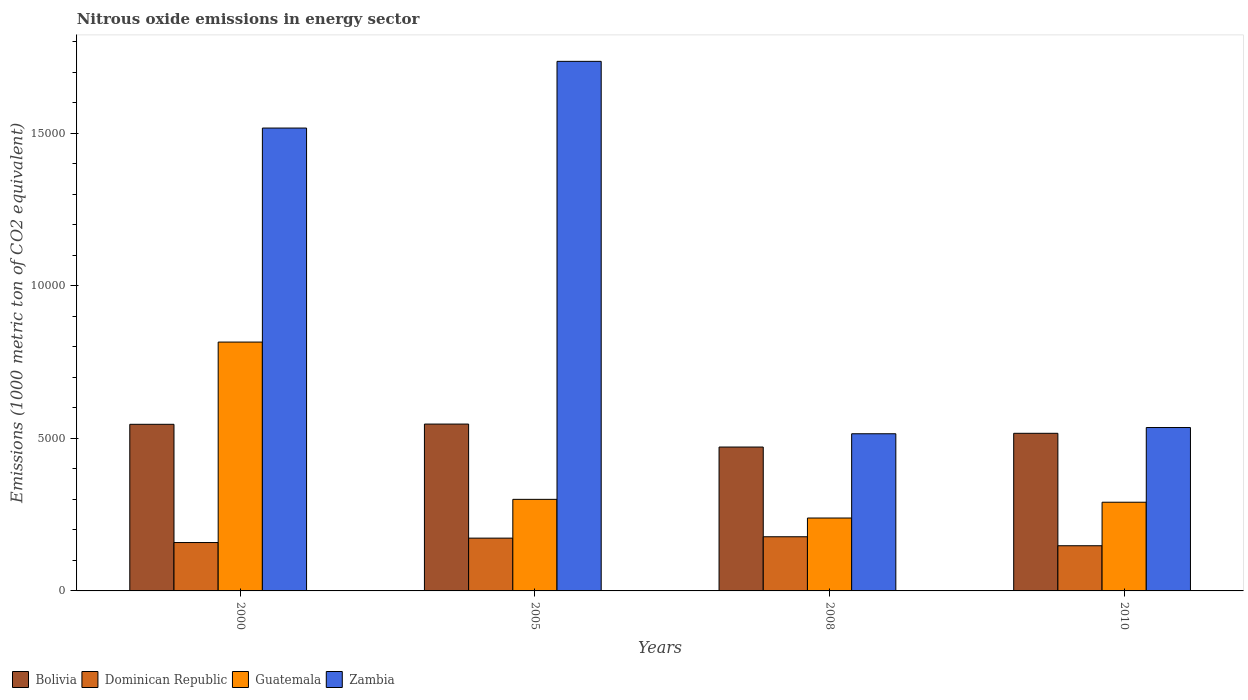How many groups of bars are there?
Provide a short and direct response. 4. Are the number of bars on each tick of the X-axis equal?
Give a very brief answer. Yes. How many bars are there on the 1st tick from the right?
Your answer should be very brief. 4. What is the amount of nitrous oxide emitted in Bolivia in 2000?
Offer a terse response. 5463.1. Across all years, what is the maximum amount of nitrous oxide emitted in Dominican Republic?
Offer a very short reply. 1775.7. Across all years, what is the minimum amount of nitrous oxide emitted in Zambia?
Provide a short and direct response. 5152.9. In which year was the amount of nitrous oxide emitted in Zambia maximum?
Give a very brief answer. 2005. What is the total amount of nitrous oxide emitted in Zambia in the graph?
Make the answer very short. 4.30e+04. What is the difference between the amount of nitrous oxide emitted in Zambia in 2000 and that in 2010?
Offer a very short reply. 9818.5. What is the difference between the amount of nitrous oxide emitted in Dominican Republic in 2010 and the amount of nitrous oxide emitted in Guatemala in 2005?
Your answer should be very brief. -1520.9. What is the average amount of nitrous oxide emitted in Dominican Republic per year?
Your response must be concise. 1643.65. In the year 2000, what is the difference between the amount of nitrous oxide emitted in Zambia and amount of nitrous oxide emitted in Dominican Republic?
Your answer should be very brief. 1.36e+04. What is the ratio of the amount of nitrous oxide emitted in Dominican Republic in 2005 to that in 2010?
Your answer should be compact. 1.17. Is the amount of nitrous oxide emitted in Guatemala in 2005 less than that in 2010?
Keep it short and to the point. No. Is the difference between the amount of nitrous oxide emitted in Zambia in 2005 and 2008 greater than the difference between the amount of nitrous oxide emitted in Dominican Republic in 2005 and 2008?
Your answer should be compact. Yes. What is the difference between the highest and the second highest amount of nitrous oxide emitted in Dominican Republic?
Make the answer very short. 44.7. What is the difference between the highest and the lowest amount of nitrous oxide emitted in Guatemala?
Keep it short and to the point. 5769.4. In how many years, is the amount of nitrous oxide emitted in Bolivia greater than the average amount of nitrous oxide emitted in Bolivia taken over all years?
Provide a short and direct response. 2. Is it the case that in every year, the sum of the amount of nitrous oxide emitted in Bolivia and amount of nitrous oxide emitted in Dominican Republic is greater than the sum of amount of nitrous oxide emitted in Zambia and amount of nitrous oxide emitted in Guatemala?
Your answer should be very brief. Yes. What does the 2nd bar from the left in 2005 represents?
Offer a very short reply. Dominican Republic. What does the 1st bar from the right in 2000 represents?
Make the answer very short. Zambia. Are all the bars in the graph horizontal?
Keep it short and to the point. No. How many legend labels are there?
Give a very brief answer. 4. How are the legend labels stacked?
Provide a succinct answer. Horizontal. What is the title of the graph?
Provide a short and direct response. Nitrous oxide emissions in energy sector. Does "Tajikistan" appear as one of the legend labels in the graph?
Offer a terse response. No. What is the label or title of the Y-axis?
Offer a terse response. Emissions (1000 metric ton of CO2 equivalent). What is the Emissions (1000 metric ton of CO2 equivalent) of Bolivia in 2000?
Keep it short and to the point. 5463.1. What is the Emissions (1000 metric ton of CO2 equivalent) in Dominican Republic in 2000?
Your answer should be very brief. 1586.4. What is the Emissions (1000 metric ton of CO2 equivalent) of Guatemala in 2000?
Your answer should be very brief. 8159.4. What is the Emissions (1000 metric ton of CO2 equivalent) in Zambia in 2000?
Your response must be concise. 1.52e+04. What is the Emissions (1000 metric ton of CO2 equivalent) of Bolivia in 2005?
Your answer should be very brief. 5470.8. What is the Emissions (1000 metric ton of CO2 equivalent) in Dominican Republic in 2005?
Offer a very short reply. 1731. What is the Emissions (1000 metric ton of CO2 equivalent) of Guatemala in 2005?
Your answer should be compact. 3002.4. What is the Emissions (1000 metric ton of CO2 equivalent) of Zambia in 2005?
Provide a succinct answer. 1.74e+04. What is the Emissions (1000 metric ton of CO2 equivalent) of Bolivia in 2008?
Give a very brief answer. 4717.4. What is the Emissions (1000 metric ton of CO2 equivalent) in Dominican Republic in 2008?
Your response must be concise. 1775.7. What is the Emissions (1000 metric ton of CO2 equivalent) in Guatemala in 2008?
Make the answer very short. 2390. What is the Emissions (1000 metric ton of CO2 equivalent) of Zambia in 2008?
Your response must be concise. 5152.9. What is the Emissions (1000 metric ton of CO2 equivalent) in Bolivia in 2010?
Provide a short and direct response. 5168. What is the Emissions (1000 metric ton of CO2 equivalent) in Dominican Republic in 2010?
Provide a short and direct response. 1481.5. What is the Emissions (1000 metric ton of CO2 equivalent) in Guatemala in 2010?
Your answer should be compact. 2908.1. What is the Emissions (1000 metric ton of CO2 equivalent) in Zambia in 2010?
Provide a succinct answer. 5357.6. Across all years, what is the maximum Emissions (1000 metric ton of CO2 equivalent) of Bolivia?
Your response must be concise. 5470.8. Across all years, what is the maximum Emissions (1000 metric ton of CO2 equivalent) in Dominican Republic?
Your answer should be very brief. 1775.7. Across all years, what is the maximum Emissions (1000 metric ton of CO2 equivalent) of Guatemala?
Your answer should be very brief. 8159.4. Across all years, what is the maximum Emissions (1000 metric ton of CO2 equivalent) in Zambia?
Your answer should be compact. 1.74e+04. Across all years, what is the minimum Emissions (1000 metric ton of CO2 equivalent) of Bolivia?
Offer a very short reply. 4717.4. Across all years, what is the minimum Emissions (1000 metric ton of CO2 equivalent) of Dominican Republic?
Give a very brief answer. 1481.5. Across all years, what is the minimum Emissions (1000 metric ton of CO2 equivalent) in Guatemala?
Provide a succinct answer. 2390. Across all years, what is the minimum Emissions (1000 metric ton of CO2 equivalent) of Zambia?
Your response must be concise. 5152.9. What is the total Emissions (1000 metric ton of CO2 equivalent) in Bolivia in the graph?
Ensure brevity in your answer.  2.08e+04. What is the total Emissions (1000 metric ton of CO2 equivalent) in Dominican Republic in the graph?
Give a very brief answer. 6574.6. What is the total Emissions (1000 metric ton of CO2 equivalent) in Guatemala in the graph?
Offer a very short reply. 1.65e+04. What is the total Emissions (1000 metric ton of CO2 equivalent) of Zambia in the graph?
Your answer should be compact. 4.30e+04. What is the difference between the Emissions (1000 metric ton of CO2 equivalent) of Bolivia in 2000 and that in 2005?
Provide a short and direct response. -7.7. What is the difference between the Emissions (1000 metric ton of CO2 equivalent) of Dominican Republic in 2000 and that in 2005?
Keep it short and to the point. -144.6. What is the difference between the Emissions (1000 metric ton of CO2 equivalent) of Guatemala in 2000 and that in 2005?
Offer a very short reply. 5157. What is the difference between the Emissions (1000 metric ton of CO2 equivalent) in Zambia in 2000 and that in 2005?
Your answer should be compact. -2187.2. What is the difference between the Emissions (1000 metric ton of CO2 equivalent) of Bolivia in 2000 and that in 2008?
Provide a succinct answer. 745.7. What is the difference between the Emissions (1000 metric ton of CO2 equivalent) of Dominican Republic in 2000 and that in 2008?
Ensure brevity in your answer.  -189.3. What is the difference between the Emissions (1000 metric ton of CO2 equivalent) in Guatemala in 2000 and that in 2008?
Your answer should be very brief. 5769.4. What is the difference between the Emissions (1000 metric ton of CO2 equivalent) of Zambia in 2000 and that in 2008?
Make the answer very short. 1.00e+04. What is the difference between the Emissions (1000 metric ton of CO2 equivalent) in Bolivia in 2000 and that in 2010?
Give a very brief answer. 295.1. What is the difference between the Emissions (1000 metric ton of CO2 equivalent) in Dominican Republic in 2000 and that in 2010?
Keep it short and to the point. 104.9. What is the difference between the Emissions (1000 metric ton of CO2 equivalent) of Guatemala in 2000 and that in 2010?
Offer a very short reply. 5251.3. What is the difference between the Emissions (1000 metric ton of CO2 equivalent) of Zambia in 2000 and that in 2010?
Your response must be concise. 9818.5. What is the difference between the Emissions (1000 metric ton of CO2 equivalent) in Bolivia in 2005 and that in 2008?
Your answer should be compact. 753.4. What is the difference between the Emissions (1000 metric ton of CO2 equivalent) in Dominican Republic in 2005 and that in 2008?
Your answer should be very brief. -44.7. What is the difference between the Emissions (1000 metric ton of CO2 equivalent) of Guatemala in 2005 and that in 2008?
Keep it short and to the point. 612.4. What is the difference between the Emissions (1000 metric ton of CO2 equivalent) of Zambia in 2005 and that in 2008?
Provide a succinct answer. 1.22e+04. What is the difference between the Emissions (1000 metric ton of CO2 equivalent) in Bolivia in 2005 and that in 2010?
Keep it short and to the point. 302.8. What is the difference between the Emissions (1000 metric ton of CO2 equivalent) of Dominican Republic in 2005 and that in 2010?
Make the answer very short. 249.5. What is the difference between the Emissions (1000 metric ton of CO2 equivalent) of Guatemala in 2005 and that in 2010?
Give a very brief answer. 94.3. What is the difference between the Emissions (1000 metric ton of CO2 equivalent) in Zambia in 2005 and that in 2010?
Keep it short and to the point. 1.20e+04. What is the difference between the Emissions (1000 metric ton of CO2 equivalent) of Bolivia in 2008 and that in 2010?
Make the answer very short. -450.6. What is the difference between the Emissions (1000 metric ton of CO2 equivalent) in Dominican Republic in 2008 and that in 2010?
Keep it short and to the point. 294.2. What is the difference between the Emissions (1000 metric ton of CO2 equivalent) of Guatemala in 2008 and that in 2010?
Your response must be concise. -518.1. What is the difference between the Emissions (1000 metric ton of CO2 equivalent) of Zambia in 2008 and that in 2010?
Offer a very short reply. -204.7. What is the difference between the Emissions (1000 metric ton of CO2 equivalent) of Bolivia in 2000 and the Emissions (1000 metric ton of CO2 equivalent) of Dominican Republic in 2005?
Ensure brevity in your answer.  3732.1. What is the difference between the Emissions (1000 metric ton of CO2 equivalent) in Bolivia in 2000 and the Emissions (1000 metric ton of CO2 equivalent) in Guatemala in 2005?
Offer a very short reply. 2460.7. What is the difference between the Emissions (1000 metric ton of CO2 equivalent) in Bolivia in 2000 and the Emissions (1000 metric ton of CO2 equivalent) in Zambia in 2005?
Your response must be concise. -1.19e+04. What is the difference between the Emissions (1000 metric ton of CO2 equivalent) in Dominican Republic in 2000 and the Emissions (1000 metric ton of CO2 equivalent) in Guatemala in 2005?
Ensure brevity in your answer.  -1416. What is the difference between the Emissions (1000 metric ton of CO2 equivalent) of Dominican Republic in 2000 and the Emissions (1000 metric ton of CO2 equivalent) of Zambia in 2005?
Ensure brevity in your answer.  -1.58e+04. What is the difference between the Emissions (1000 metric ton of CO2 equivalent) of Guatemala in 2000 and the Emissions (1000 metric ton of CO2 equivalent) of Zambia in 2005?
Provide a succinct answer. -9203.9. What is the difference between the Emissions (1000 metric ton of CO2 equivalent) of Bolivia in 2000 and the Emissions (1000 metric ton of CO2 equivalent) of Dominican Republic in 2008?
Keep it short and to the point. 3687.4. What is the difference between the Emissions (1000 metric ton of CO2 equivalent) in Bolivia in 2000 and the Emissions (1000 metric ton of CO2 equivalent) in Guatemala in 2008?
Offer a terse response. 3073.1. What is the difference between the Emissions (1000 metric ton of CO2 equivalent) in Bolivia in 2000 and the Emissions (1000 metric ton of CO2 equivalent) in Zambia in 2008?
Your response must be concise. 310.2. What is the difference between the Emissions (1000 metric ton of CO2 equivalent) in Dominican Republic in 2000 and the Emissions (1000 metric ton of CO2 equivalent) in Guatemala in 2008?
Your response must be concise. -803.6. What is the difference between the Emissions (1000 metric ton of CO2 equivalent) in Dominican Republic in 2000 and the Emissions (1000 metric ton of CO2 equivalent) in Zambia in 2008?
Keep it short and to the point. -3566.5. What is the difference between the Emissions (1000 metric ton of CO2 equivalent) in Guatemala in 2000 and the Emissions (1000 metric ton of CO2 equivalent) in Zambia in 2008?
Ensure brevity in your answer.  3006.5. What is the difference between the Emissions (1000 metric ton of CO2 equivalent) of Bolivia in 2000 and the Emissions (1000 metric ton of CO2 equivalent) of Dominican Republic in 2010?
Make the answer very short. 3981.6. What is the difference between the Emissions (1000 metric ton of CO2 equivalent) in Bolivia in 2000 and the Emissions (1000 metric ton of CO2 equivalent) in Guatemala in 2010?
Make the answer very short. 2555. What is the difference between the Emissions (1000 metric ton of CO2 equivalent) in Bolivia in 2000 and the Emissions (1000 metric ton of CO2 equivalent) in Zambia in 2010?
Offer a very short reply. 105.5. What is the difference between the Emissions (1000 metric ton of CO2 equivalent) in Dominican Republic in 2000 and the Emissions (1000 metric ton of CO2 equivalent) in Guatemala in 2010?
Offer a very short reply. -1321.7. What is the difference between the Emissions (1000 metric ton of CO2 equivalent) of Dominican Republic in 2000 and the Emissions (1000 metric ton of CO2 equivalent) of Zambia in 2010?
Make the answer very short. -3771.2. What is the difference between the Emissions (1000 metric ton of CO2 equivalent) of Guatemala in 2000 and the Emissions (1000 metric ton of CO2 equivalent) of Zambia in 2010?
Your response must be concise. 2801.8. What is the difference between the Emissions (1000 metric ton of CO2 equivalent) of Bolivia in 2005 and the Emissions (1000 metric ton of CO2 equivalent) of Dominican Republic in 2008?
Offer a very short reply. 3695.1. What is the difference between the Emissions (1000 metric ton of CO2 equivalent) of Bolivia in 2005 and the Emissions (1000 metric ton of CO2 equivalent) of Guatemala in 2008?
Your response must be concise. 3080.8. What is the difference between the Emissions (1000 metric ton of CO2 equivalent) of Bolivia in 2005 and the Emissions (1000 metric ton of CO2 equivalent) of Zambia in 2008?
Offer a terse response. 317.9. What is the difference between the Emissions (1000 metric ton of CO2 equivalent) of Dominican Republic in 2005 and the Emissions (1000 metric ton of CO2 equivalent) of Guatemala in 2008?
Make the answer very short. -659. What is the difference between the Emissions (1000 metric ton of CO2 equivalent) in Dominican Republic in 2005 and the Emissions (1000 metric ton of CO2 equivalent) in Zambia in 2008?
Offer a terse response. -3421.9. What is the difference between the Emissions (1000 metric ton of CO2 equivalent) of Guatemala in 2005 and the Emissions (1000 metric ton of CO2 equivalent) of Zambia in 2008?
Your answer should be very brief. -2150.5. What is the difference between the Emissions (1000 metric ton of CO2 equivalent) of Bolivia in 2005 and the Emissions (1000 metric ton of CO2 equivalent) of Dominican Republic in 2010?
Your response must be concise. 3989.3. What is the difference between the Emissions (1000 metric ton of CO2 equivalent) of Bolivia in 2005 and the Emissions (1000 metric ton of CO2 equivalent) of Guatemala in 2010?
Provide a short and direct response. 2562.7. What is the difference between the Emissions (1000 metric ton of CO2 equivalent) in Bolivia in 2005 and the Emissions (1000 metric ton of CO2 equivalent) in Zambia in 2010?
Ensure brevity in your answer.  113.2. What is the difference between the Emissions (1000 metric ton of CO2 equivalent) of Dominican Republic in 2005 and the Emissions (1000 metric ton of CO2 equivalent) of Guatemala in 2010?
Your answer should be very brief. -1177.1. What is the difference between the Emissions (1000 metric ton of CO2 equivalent) of Dominican Republic in 2005 and the Emissions (1000 metric ton of CO2 equivalent) of Zambia in 2010?
Your answer should be compact. -3626.6. What is the difference between the Emissions (1000 metric ton of CO2 equivalent) in Guatemala in 2005 and the Emissions (1000 metric ton of CO2 equivalent) in Zambia in 2010?
Your answer should be very brief. -2355.2. What is the difference between the Emissions (1000 metric ton of CO2 equivalent) of Bolivia in 2008 and the Emissions (1000 metric ton of CO2 equivalent) of Dominican Republic in 2010?
Make the answer very short. 3235.9. What is the difference between the Emissions (1000 metric ton of CO2 equivalent) of Bolivia in 2008 and the Emissions (1000 metric ton of CO2 equivalent) of Guatemala in 2010?
Offer a very short reply. 1809.3. What is the difference between the Emissions (1000 metric ton of CO2 equivalent) of Bolivia in 2008 and the Emissions (1000 metric ton of CO2 equivalent) of Zambia in 2010?
Keep it short and to the point. -640.2. What is the difference between the Emissions (1000 metric ton of CO2 equivalent) of Dominican Republic in 2008 and the Emissions (1000 metric ton of CO2 equivalent) of Guatemala in 2010?
Your answer should be very brief. -1132.4. What is the difference between the Emissions (1000 metric ton of CO2 equivalent) in Dominican Republic in 2008 and the Emissions (1000 metric ton of CO2 equivalent) in Zambia in 2010?
Make the answer very short. -3581.9. What is the difference between the Emissions (1000 metric ton of CO2 equivalent) in Guatemala in 2008 and the Emissions (1000 metric ton of CO2 equivalent) in Zambia in 2010?
Give a very brief answer. -2967.6. What is the average Emissions (1000 metric ton of CO2 equivalent) in Bolivia per year?
Your answer should be compact. 5204.82. What is the average Emissions (1000 metric ton of CO2 equivalent) of Dominican Republic per year?
Offer a terse response. 1643.65. What is the average Emissions (1000 metric ton of CO2 equivalent) in Guatemala per year?
Your answer should be compact. 4114.98. What is the average Emissions (1000 metric ton of CO2 equivalent) in Zambia per year?
Keep it short and to the point. 1.08e+04. In the year 2000, what is the difference between the Emissions (1000 metric ton of CO2 equivalent) in Bolivia and Emissions (1000 metric ton of CO2 equivalent) in Dominican Republic?
Your answer should be compact. 3876.7. In the year 2000, what is the difference between the Emissions (1000 metric ton of CO2 equivalent) of Bolivia and Emissions (1000 metric ton of CO2 equivalent) of Guatemala?
Give a very brief answer. -2696.3. In the year 2000, what is the difference between the Emissions (1000 metric ton of CO2 equivalent) of Bolivia and Emissions (1000 metric ton of CO2 equivalent) of Zambia?
Your response must be concise. -9713. In the year 2000, what is the difference between the Emissions (1000 metric ton of CO2 equivalent) in Dominican Republic and Emissions (1000 metric ton of CO2 equivalent) in Guatemala?
Your response must be concise. -6573. In the year 2000, what is the difference between the Emissions (1000 metric ton of CO2 equivalent) in Dominican Republic and Emissions (1000 metric ton of CO2 equivalent) in Zambia?
Provide a succinct answer. -1.36e+04. In the year 2000, what is the difference between the Emissions (1000 metric ton of CO2 equivalent) of Guatemala and Emissions (1000 metric ton of CO2 equivalent) of Zambia?
Offer a very short reply. -7016.7. In the year 2005, what is the difference between the Emissions (1000 metric ton of CO2 equivalent) of Bolivia and Emissions (1000 metric ton of CO2 equivalent) of Dominican Republic?
Provide a succinct answer. 3739.8. In the year 2005, what is the difference between the Emissions (1000 metric ton of CO2 equivalent) in Bolivia and Emissions (1000 metric ton of CO2 equivalent) in Guatemala?
Your answer should be very brief. 2468.4. In the year 2005, what is the difference between the Emissions (1000 metric ton of CO2 equivalent) in Bolivia and Emissions (1000 metric ton of CO2 equivalent) in Zambia?
Give a very brief answer. -1.19e+04. In the year 2005, what is the difference between the Emissions (1000 metric ton of CO2 equivalent) in Dominican Republic and Emissions (1000 metric ton of CO2 equivalent) in Guatemala?
Offer a terse response. -1271.4. In the year 2005, what is the difference between the Emissions (1000 metric ton of CO2 equivalent) of Dominican Republic and Emissions (1000 metric ton of CO2 equivalent) of Zambia?
Offer a very short reply. -1.56e+04. In the year 2005, what is the difference between the Emissions (1000 metric ton of CO2 equivalent) of Guatemala and Emissions (1000 metric ton of CO2 equivalent) of Zambia?
Make the answer very short. -1.44e+04. In the year 2008, what is the difference between the Emissions (1000 metric ton of CO2 equivalent) of Bolivia and Emissions (1000 metric ton of CO2 equivalent) of Dominican Republic?
Offer a very short reply. 2941.7. In the year 2008, what is the difference between the Emissions (1000 metric ton of CO2 equivalent) of Bolivia and Emissions (1000 metric ton of CO2 equivalent) of Guatemala?
Your answer should be very brief. 2327.4. In the year 2008, what is the difference between the Emissions (1000 metric ton of CO2 equivalent) in Bolivia and Emissions (1000 metric ton of CO2 equivalent) in Zambia?
Ensure brevity in your answer.  -435.5. In the year 2008, what is the difference between the Emissions (1000 metric ton of CO2 equivalent) of Dominican Republic and Emissions (1000 metric ton of CO2 equivalent) of Guatemala?
Provide a short and direct response. -614.3. In the year 2008, what is the difference between the Emissions (1000 metric ton of CO2 equivalent) of Dominican Republic and Emissions (1000 metric ton of CO2 equivalent) of Zambia?
Offer a very short reply. -3377.2. In the year 2008, what is the difference between the Emissions (1000 metric ton of CO2 equivalent) of Guatemala and Emissions (1000 metric ton of CO2 equivalent) of Zambia?
Give a very brief answer. -2762.9. In the year 2010, what is the difference between the Emissions (1000 metric ton of CO2 equivalent) in Bolivia and Emissions (1000 metric ton of CO2 equivalent) in Dominican Republic?
Offer a very short reply. 3686.5. In the year 2010, what is the difference between the Emissions (1000 metric ton of CO2 equivalent) in Bolivia and Emissions (1000 metric ton of CO2 equivalent) in Guatemala?
Provide a short and direct response. 2259.9. In the year 2010, what is the difference between the Emissions (1000 metric ton of CO2 equivalent) of Bolivia and Emissions (1000 metric ton of CO2 equivalent) of Zambia?
Your answer should be very brief. -189.6. In the year 2010, what is the difference between the Emissions (1000 metric ton of CO2 equivalent) in Dominican Republic and Emissions (1000 metric ton of CO2 equivalent) in Guatemala?
Your answer should be compact. -1426.6. In the year 2010, what is the difference between the Emissions (1000 metric ton of CO2 equivalent) of Dominican Republic and Emissions (1000 metric ton of CO2 equivalent) of Zambia?
Your response must be concise. -3876.1. In the year 2010, what is the difference between the Emissions (1000 metric ton of CO2 equivalent) of Guatemala and Emissions (1000 metric ton of CO2 equivalent) of Zambia?
Make the answer very short. -2449.5. What is the ratio of the Emissions (1000 metric ton of CO2 equivalent) in Dominican Republic in 2000 to that in 2005?
Offer a very short reply. 0.92. What is the ratio of the Emissions (1000 metric ton of CO2 equivalent) of Guatemala in 2000 to that in 2005?
Your response must be concise. 2.72. What is the ratio of the Emissions (1000 metric ton of CO2 equivalent) in Zambia in 2000 to that in 2005?
Give a very brief answer. 0.87. What is the ratio of the Emissions (1000 metric ton of CO2 equivalent) of Bolivia in 2000 to that in 2008?
Your answer should be very brief. 1.16. What is the ratio of the Emissions (1000 metric ton of CO2 equivalent) of Dominican Republic in 2000 to that in 2008?
Your response must be concise. 0.89. What is the ratio of the Emissions (1000 metric ton of CO2 equivalent) of Guatemala in 2000 to that in 2008?
Offer a very short reply. 3.41. What is the ratio of the Emissions (1000 metric ton of CO2 equivalent) of Zambia in 2000 to that in 2008?
Your response must be concise. 2.95. What is the ratio of the Emissions (1000 metric ton of CO2 equivalent) of Bolivia in 2000 to that in 2010?
Your response must be concise. 1.06. What is the ratio of the Emissions (1000 metric ton of CO2 equivalent) of Dominican Republic in 2000 to that in 2010?
Your answer should be very brief. 1.07. What is the ratio of the Emissions (1000 metric ton of CO2 equivalent) of Guatemala in 2000 to that in 2010?
Provide a short and direct response. 2.81. What is the ratio of the Emissions (1000 metric ton of CO2 equivalent) in Zambia in 2000 to that in 2010?
Make the answer very short. 2.83. What is the ratio of the Emissions (1000 metric ton of CO2 equivalent) in Bolivia in 2005 to that in 2008?
Make the answer very short. 1.16. What is the ratio of the Emissions (1000 metric ton of CO2 equivalent) of Dominican Republic in 2005 to that in 2008?
Your answer should be compact. 0.97. What is the ratio of the Emissions (1000 metric ton of CO2 equivalent) in Guatemala in 2005 to that in 2008?
Give a very brief answer. 1.26. What is the ratio of the Emissions (1000 metric ton of CO2 equivalent) in Zambia in 2005 to that in 2008?
Provide a succinct answer. 3.37. What is the ratio of the Emissions (1000 metric ton of CO2 equivalent) of Bolivia in 2005 to that in 2010?
Give a very brief answer. 1.06. What is the ratio of the Emissions (1000 metric ton of CO2 equivalent) in Dominican Republic in 2005 to that in 2010?
Your answer should be compact. 1.17. What is the ratio of the Emissions (1000 metric ton of CO2 equivalent) of Guatemala in 2005 to that in 2010?
Ensure brevity in your answer.  1.03. What is the ratio of the Emissions (1000 metric ton of CO2 equivalent) of Zambia in 2005 to that in 2010?
Offer a very short reply. 3.24. What is the ratio of the Emissions (1000 metric ton of CO2 equivalent) in Bolivia in 2008 to that in 2010?
Provide a short and direct response. 0.91. What is the ratio of the Emissions (1000 metric ton of CO2 equivalent) of Dominican Republic in 2008 to that in 2010?
Offer a very short reply. 1.2. What is the ratio of the Emissions (1000 metric ton of CO2 equivalent) in Guatemala in 2008 to that in 2010?
Your answer should be very brief. 0.82. What is the ratio of the Emissions (1000 metric ton of CO2 equivalent) in Zambia in 2008 to that in 2010?
Offer a terse response. 0.96. What is the difference between the highest and the second highest Emissions (1000 metric ton of CO2 equivalent) of Dominican Republic?
Your answer should be compact. 44.7. What is the difference between the highest and the second highest Emissions (1000 metric ton of CO2 equivalent) of Guatemala?
Your answer should be very brief. 5157. What is the difference between the highest and the second highest Emissions (1000 metric ton of CO2 equivalent) of Zambia?
Offer a very short reply. 2187.2. What is the difference between the highest and the lowest Emissions (1000 metric ton of CO2 equivalent) in Bolivia?
Offer a very short reply. 753.4. What is the difference between the highest and the lowest Emissions (1000 metric ton of CO2 equivalent) in Dominican Republic?
Ensure brevity in your answer.  294.2. What is the difference between the highest and the lowest Emissions (1000 metric ton of CO2 equivalent) of Guatemala?
Give a very brief answer. 5769.4. What is the difference between the highest and the lowest Emissions (1000 metric ton of CO2 equivalent) in Zambia?
Your answer should be compact. 1.22e+04. 